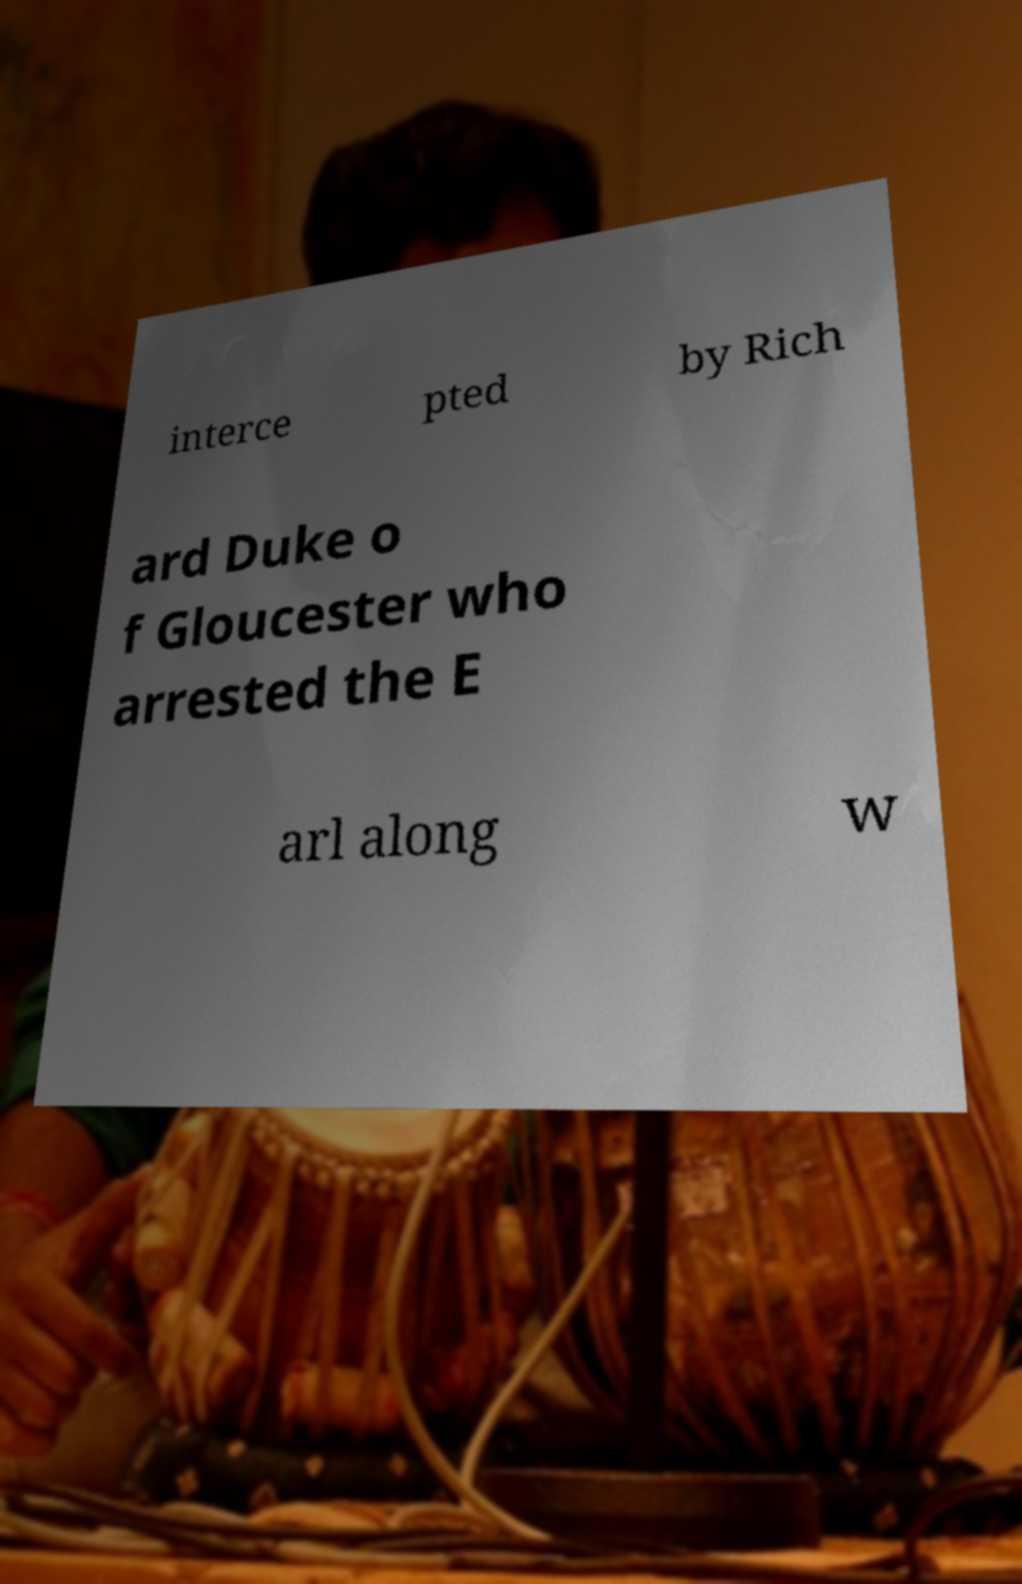Can you read and provide the text displayed in the image?This photo seems to have some interesting text. Can you extract and type it out for me? interce pted by Rich ard Duke o f Gloucester who arrested the E arl along w 